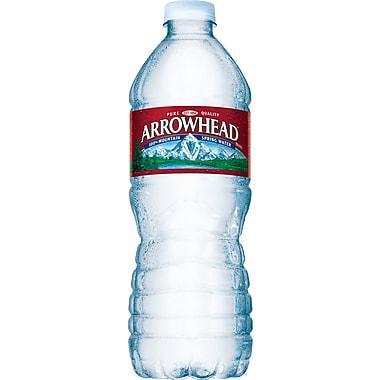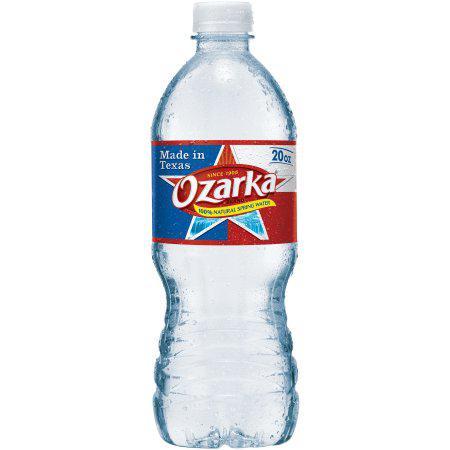The first image is the image on the left, the second image is the image on the right. For the images shown, is this caption "Two bottles of water are the same shape and coloring, and have white caps, but have different labels." true? Answer yes or no. Yes. 